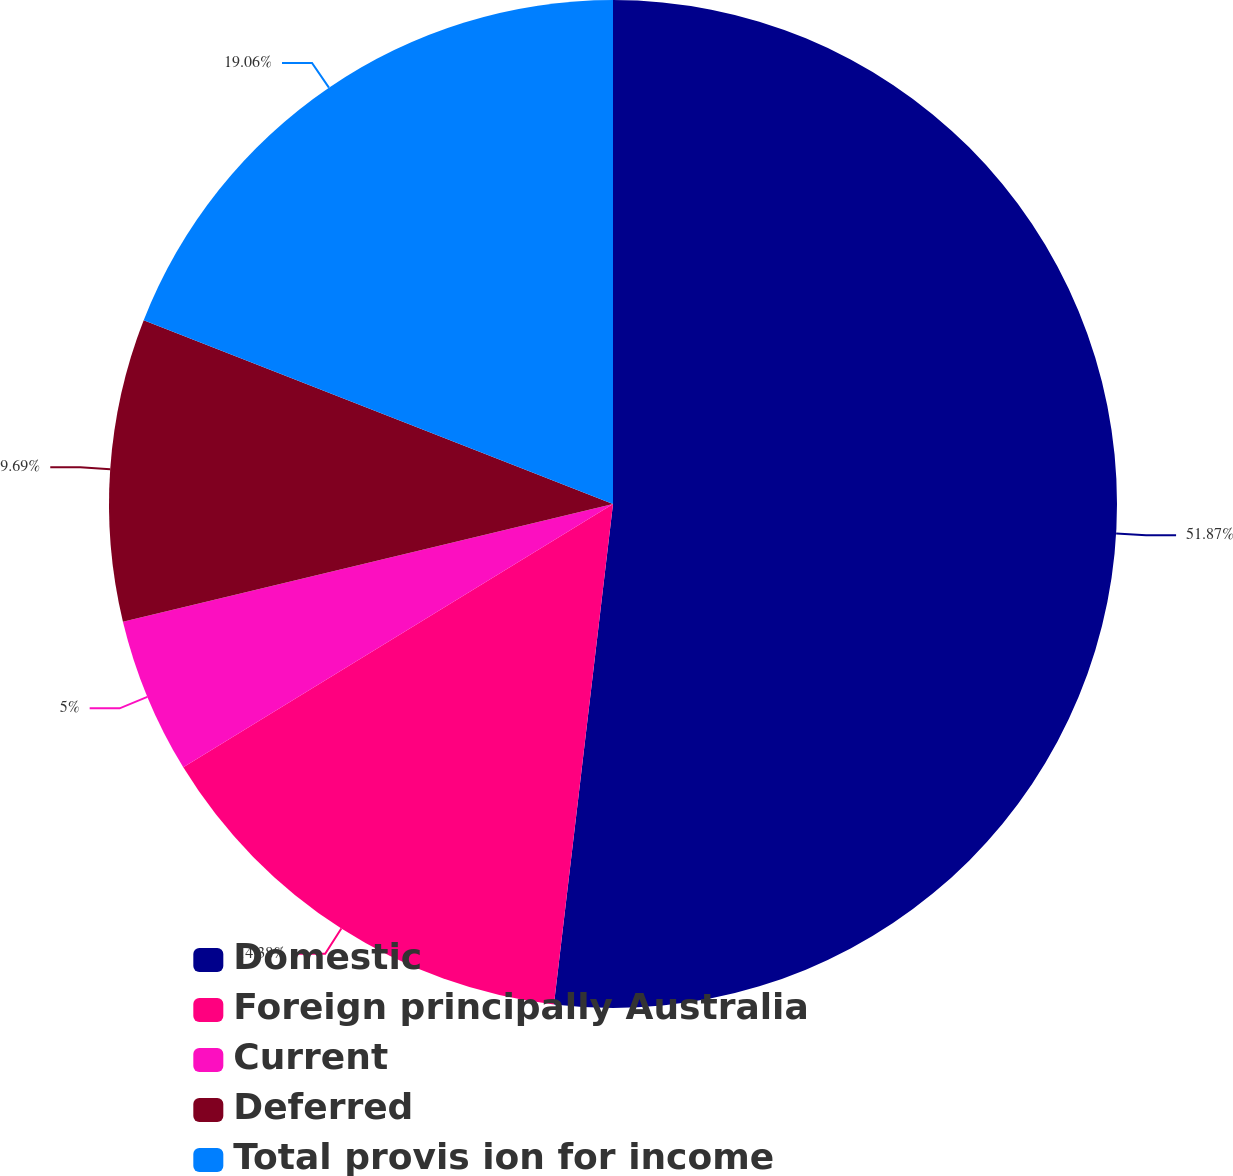<chart> <loc_0><loc_0><loc_500><loc_500><pie_chart><fcel>Domestic<fcel>Foreign principally Australia<fcel>Current<fcel>Deferred<fcel>Total provis ion for income<nl><fcel>51.87%<fcel>14.38%<fcel>5.0%<fcel>9.69%<fcel>19.06%<nl></chart> 